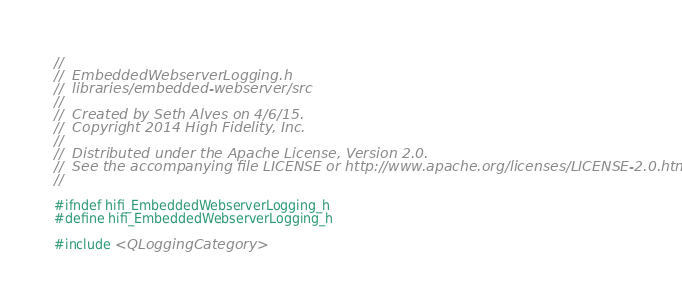Convert code to text. <code><loc_0><loc_0><loc_500><loc_500><_C_>//
//  EmbeddedWebserverLogging.h
//  libraries/embedded-webserver/src
//
//  Created by Seth Alves on 4/6/15.
//  Copyright 2014 High Fidelity, Inc.
//
//  Distributed under the Apache License, Version 2.0.
//  See the accompanying file LICENSE or http://www.apache.org/licenses/LICENSE-2.0.html
//

#ifndef hifi_EmbeddedWebserverLogging_h
#define hifi_EmbeddedWebserverLogging_h

#include <QLoggingCategory>
</code> 